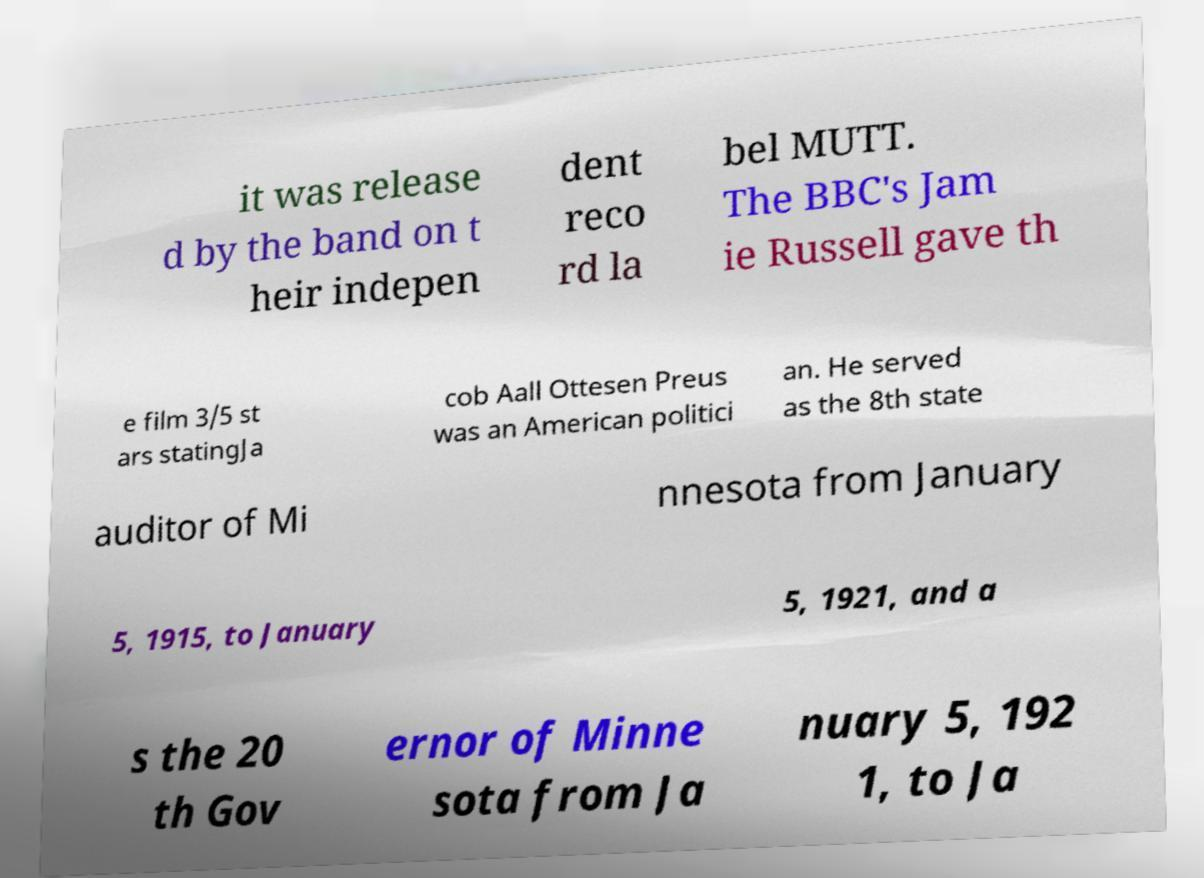What messages or text are displayed in this image? I need them in a readable, typed format. it was release d by the band on t heir indepen dent reco rd la bel MUTT. The BBC's Jam ie Russell gave th e film 3/5 st ars statingJa cob Aall Ottesen Preus was an American politici an. He served as the 8th state auditor of Mi nnesota from January 5, 1915, to January 5, 1921, and a s the 20 th Gov ernor of Minne sota from Ja nuary 5, 192 1, to Ja 